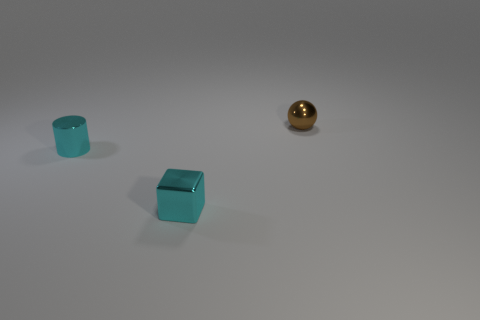There is a small object behind the cyan object that is behind the tiny cyan metallic object to the right of the small cyan cylinder; what is it made of?
Your response must be concise. Metal. Are there any red rubber spheres that have the same size as the cyan shiny cylinder?
Your answer should be very brief. No. There is a cyan cube that is the same size as the cyan cylinder; what is it made of?
Offer a terse response. Metal. The cyan object in front of the small cyan cylinder has what shape?
Your answer should be compact. Cube. Do the small brown object to the right of the cyan block and the tiny thing that is in front of the cyan metal cylinder have the same material?
Provide a short and direct response. Yes. What is the material of the thing that is the same color as the tiny block?
Provide a succinct answer. Metal. What number of things are cyan shiny cylinders or objects that are on the right side of the tiny cylinder?
Offer a terse response. 3. What material is the ball?
Provide a short and direct response. Metal. There is a thing that is in front of the cyan shiny thing behind the metal cube; what is its color?
Provide a succinct answer. Cyan. How many matte things are small things or cubes?
Provide a short and direct response. 0. 